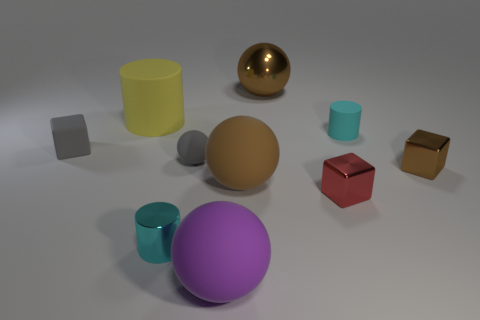Is there anything else of the same color as the big shiny object?
Keep it short and to the point. Yes. There is a rubber cylinder that is right of the small red object; what is its size?
Offer a very short reply. Small. There is a tiny matte sphere; is its color the same as the tiny cube that is to the left of the large metallic sphere?
Offer a terse response. Yes. How many other things are there of the same material as the brown cube?
Keep it short and to the point. 3. Are there more large cyan cubes than small cyan cylinders?
Provide a short and direct response. No. Do the shiny block that is to the left of the small brown shiny block and the small matte block have the same color?
Give a very brief answer. No. What color is the metallic cylinder?
Keep it short and to the point. Cyan. Are there any large matte objects that are behind the small block on the left side of the tiny ball?
Offer a very short reply. Yes. There is a tiny cyan object that is on the right side of the matte sphere in front of the small cyan metallic object; what is its shape?
Keep it short and to the point. Cylinder. Are there fewer large brown shiny cylinders than small red metallic objects?
Provide a succinct answer. Yes. 